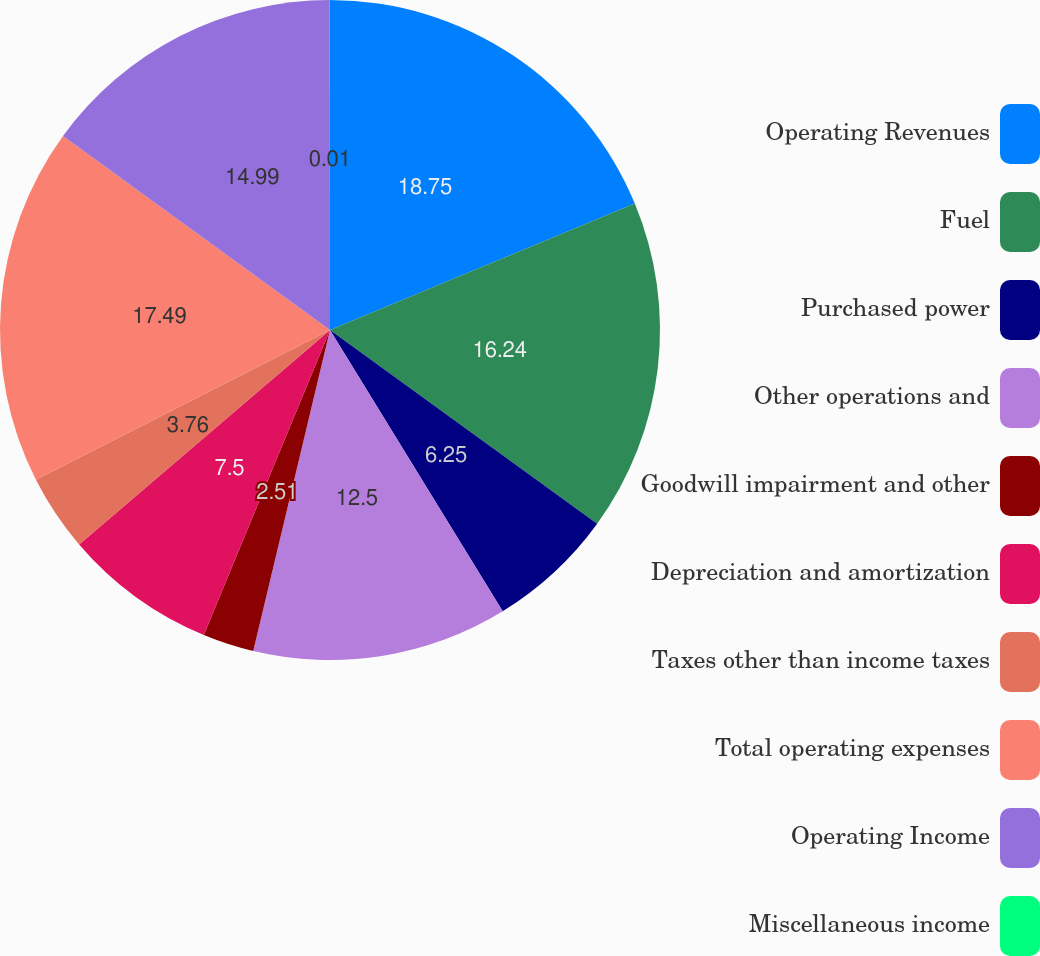Convert chart to OTSL. <chart><loc_0><loc_0><loc_500><loc_500><pie_chart><fcel>Operating Revenues<fcel>Fuel<fcel>Purchased power<fcel>Other operations and<fcel>Goodwill impairment and other<fcel>Depreciation and amortization<fcel>Taxes other than income taxes<fcel>Total operating expenses<fcel>Operating Income<fcel>Miscellaneous income<nl><fcel>18.74%<fcel>16.24%<fcel>6.25%<fcel>12.5%<fcel>2.51%<fcel>7.5%<fcel>3.76%<fcel>17.49%<fcel>14.99%<fcel>0.01%<nl></chart> 